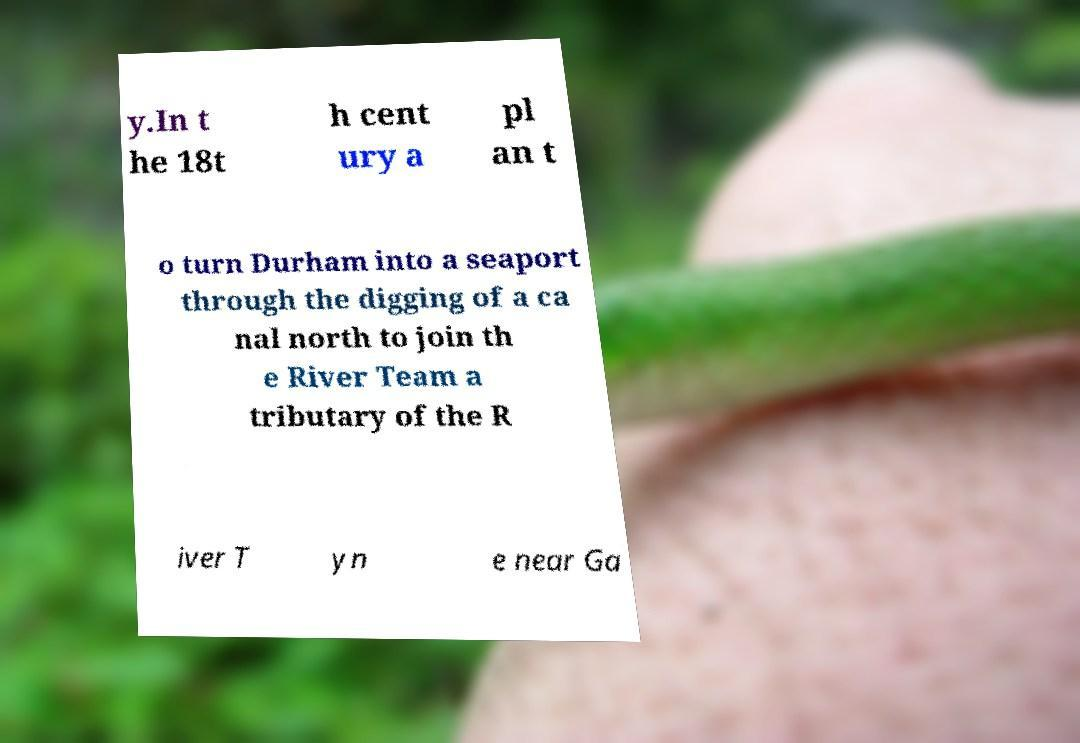For documentation purposes, I need the text within this image transcribed. Could you provide that? y.In t he 18t h cent ury a pl an t o turn Durham into a seaport through the digging of a ca nal north to join th e River Team a tributary of the R iver T yn e near Ga 